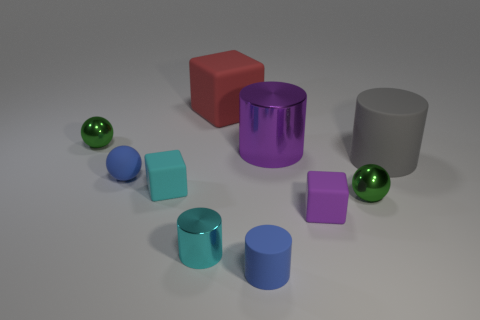Is the color of the rubber ball the same as the tiny matte cylinder?
Give a very brief answer. Yes. What material is the block that is the same color as the large metallic object?
Your answer should be very brief. Rubber. Is the number of tiny cyan rubber cubes that are behind the large cube less than the number of small purple matte blocks right of the tiny blue cylinder?
Your answer should be compact. Yes. Is the material of the big red thing the same as the small cyan cylinder?
Make the answer very short. No. There is a thing that is on the right side of the tiny rubber ball and behind the purple metal cylinder; what is its size?
Your answer should be compact. Large. There is a cyan shiny thing that is the same size as the blue matte ball; what shape is it?
Make the answer very short. Cylinder. There is a small green thing in front of the green ball that is on the left side of the small rubber cylinder that is in front of the large matte block; what is its material?
Keep it short and to the point. Metal. Is the shape of the big rubber object behind the purple cylinder the same as the small purple thing to the right of the tiny cyan cube?
Keep it short and to the point. Yes. What number of other objects are there of the same material as the big purple object?
Provide a short and direct response. 3. Is the big red object that is behind the large purple cylinder made of the same material as the cylinder behind the gray cylinder?
Your answer should be very brief. No. 